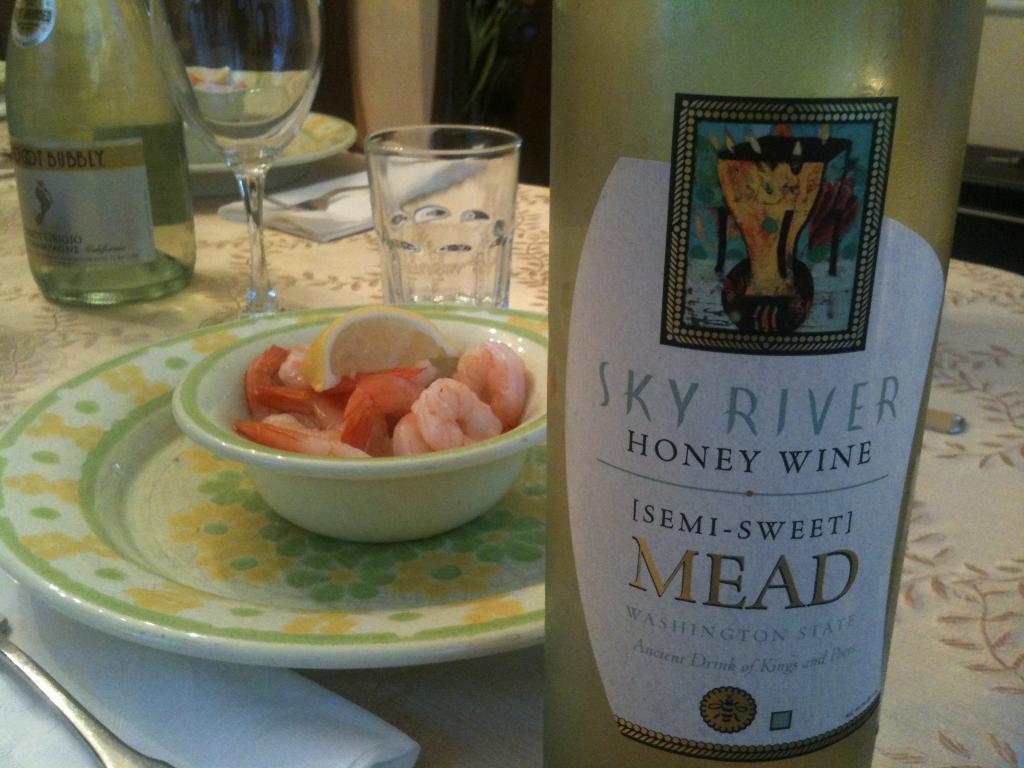Describe this image in one or two sentences. This image is taken indoors. In the background there is a wall. At the bottom of the image there is a table with a table cloth, a glass, a wine glass, a few tissue papers, forks, two plates and two wine bottles on it. In the middle of the image there is a bowl with shrimps and a lemon slice on the plate. 